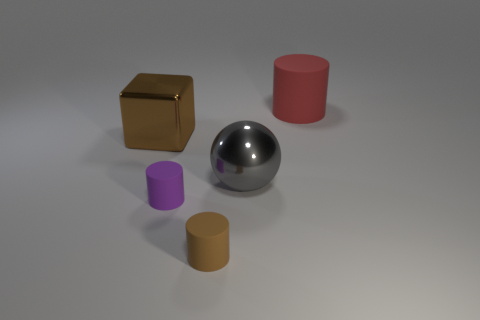Is there any other thing that has the same shape as the brown metallic object?
Ensure brevity in your answer.  No. Is the number of purple rubber cylinders in front of the metal block greater than the number of large red cubes?
Keep it short and to the point. Yes. How many cubes are to the right of the shiny object that is on the left side of the brown cylinder?
Make the answer very short. 0. The brown object to the right of the shiny object that is behind the large object in front of the big brown object is what shape?
Your response must be concise. Cylinder. The gray shiny object is what size?
Your answer should be compact. Large. Is there a brown object made of the same material as the purple cylinder?
Offer a terse response. Yes. There is a brown object that is the same shape as the small purple object; what is its size?
Provide a short and direct response. Small. Is the number of brown cylinders behind the brown matte cylinder the same as the number of small green metal cylinders?
Provide a short and direct response. Yes. There is a object that is on the right side of the gray metal ball; does it have the same shape as the small purple object?
Ensure brevity in your answer.  Yes. What shape is the purple object?
Give a very brief answer. Cylinder. 